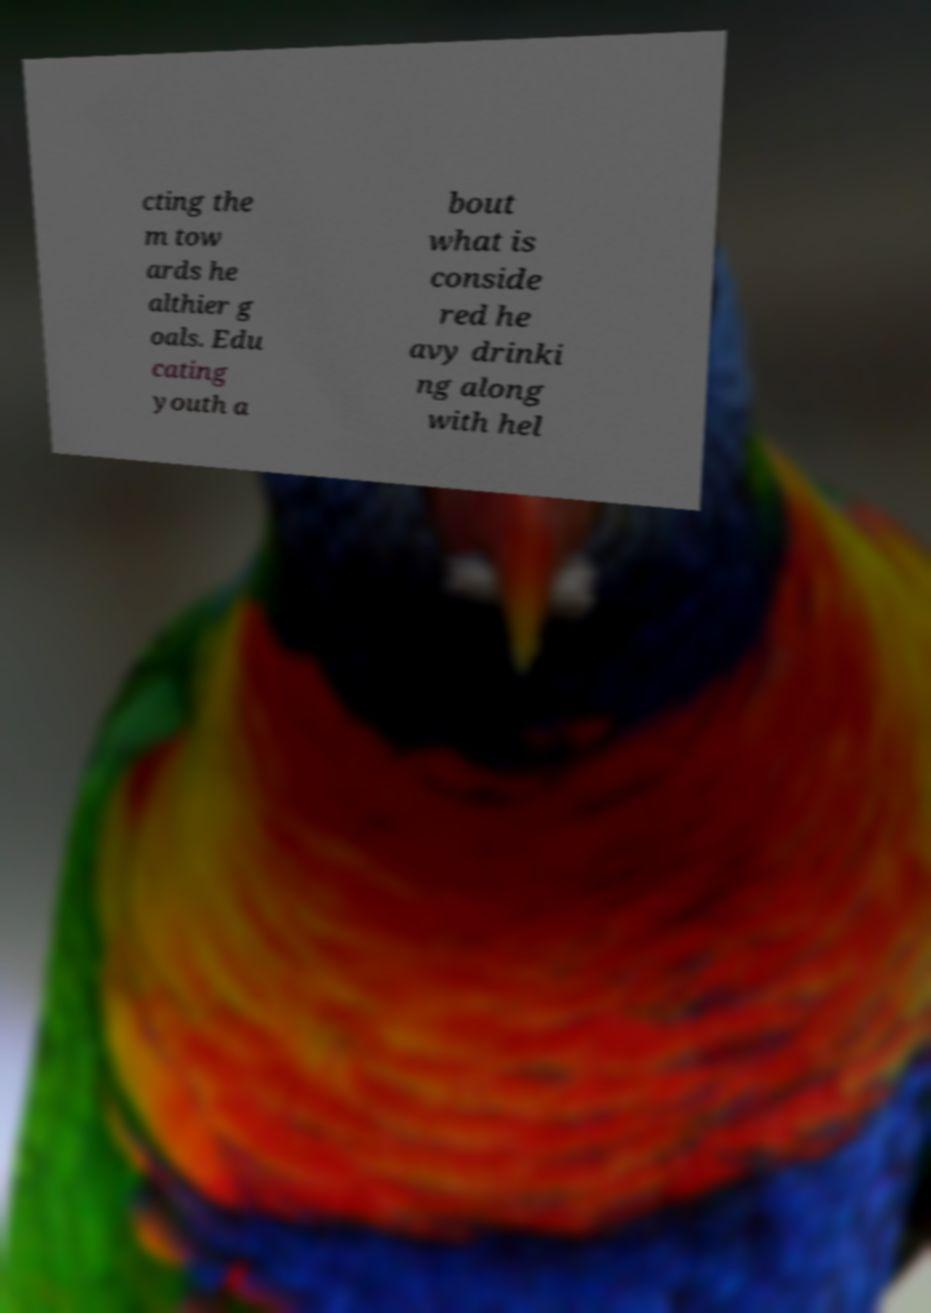Can you accurately transcribe the text from the provided image for me? cting the m tow ards he althier g oals. Edu cating youth a bout what is conside red he avy drinki ng along with hel 